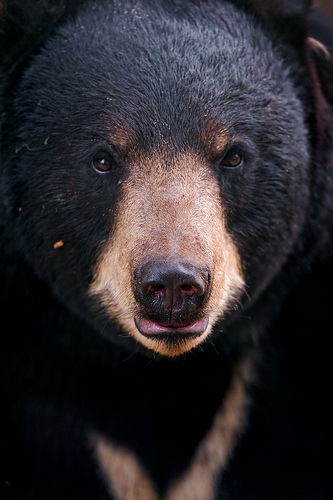Please provide the bounding box coordinate of the region this sentence describes: the nose is black. The bounding box coordinates for the black nose of the bear are [0.43, 0.49, 0.62, 0.67]. The nose is distinctly black, standing out against the lighter fur on the muzzle. 